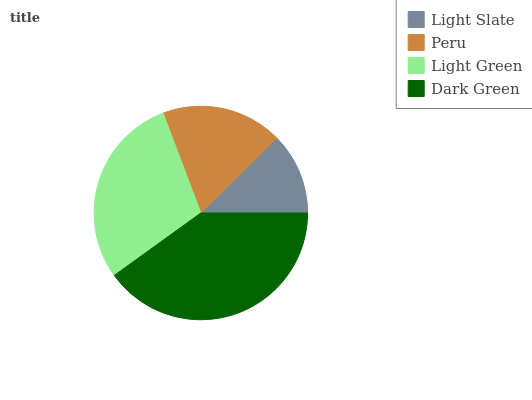Is Light Slate the minimum?
Answer yes or no. Yes. Is Dark Green the maximum?
Answer yes or no. Yes. Is Peru the minimum?
Answer yes or no. No. Is Peru the maximum?
Answer yes or no. No. Is Peru greater than Light Slate?
Answer yes or no. Yes. Is Light Slate less than Peru?
Answer yes or no. Yes. Is Light Slate greater than Peru?
Answer yes or no. No. Is Peru less than Light Slate?
Answer yes or no. No. Is Light Green the high median?
Answer yes or no. Yes. Is Peru the low median?
Answer yes or no. Yes. Is Peru the high median?
Answer yes or no. No. Is Light Green the low median?
Answer yes or no. No. 